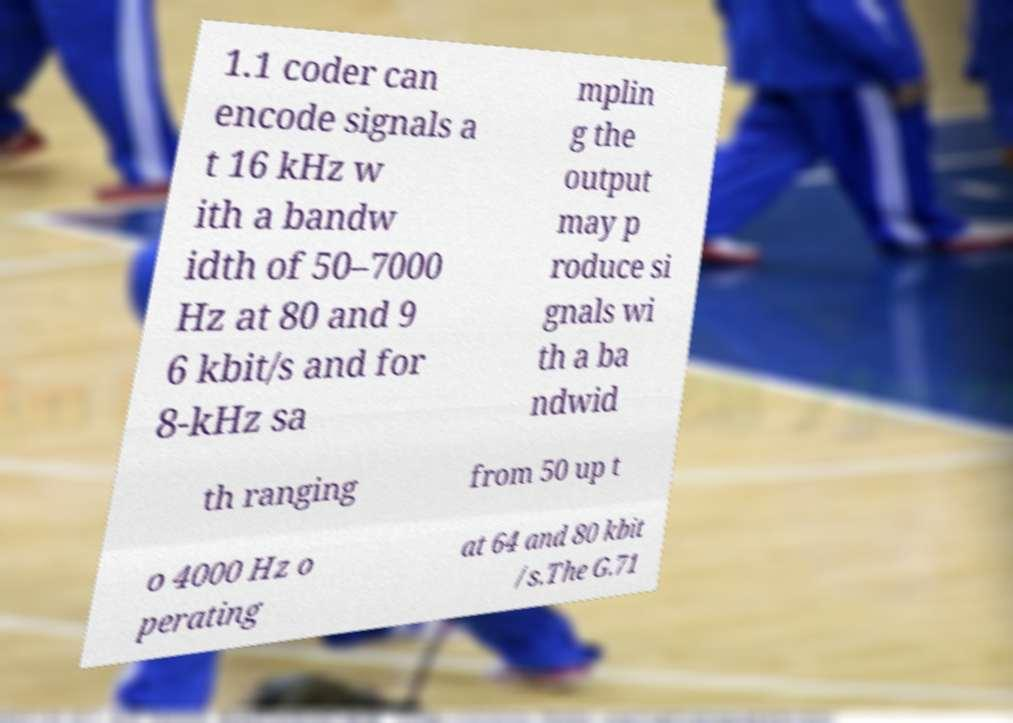Can you read and provide the text displayed in the image?This photo seems to have some interesting text. Can you extract and type it out for me? 1.1 coder can encode signals a t 16 kHz w ith a bandw idth of 50–7000 Hz at 80 and 9 6 kbit/s and for 8-kHz sa mplin g the output may p roduce si gnals wi th a ba ndwid th ranging from 50 up t o 4000 Hz o perating at 64 and 80 kbit /s.The G.71 